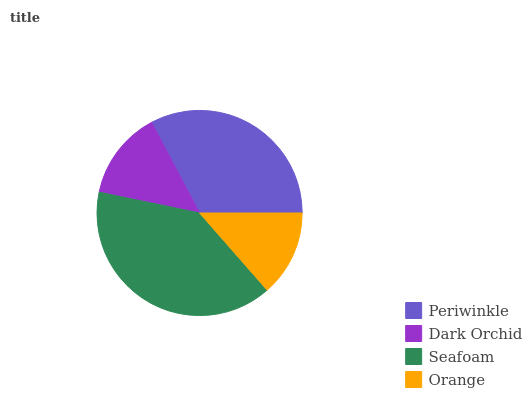Is Orange the minimum?
Answer yes or no. Yes. Is Seafoam the maximum?
Answer yes or no. Yes. Is Dark Orchid the minimum?
Answer yes or no. No. Is Dark Orchid the maximum?
Answer yes or no. No. Is Periwinkle greater than Dark Orchid?
Answer yes or no. Yes. Is Dark Orchid less than Periwinkle?
Answer yes or no. Yes. Is Dark Orchid greater than Periwinkle?
Answer yes or no. No. Is Periwinkle less than Dark Orchid?
Answer yes or no. No. Is Periwinkle the high median?
Answer yes or no. Yes. Is Dark Orchid the low median?
Answer yes or no. Yes. Is Seafoam the high median?
Answer yes or no. No. Is Seafoam the low median?
Answer yes or no. No. 